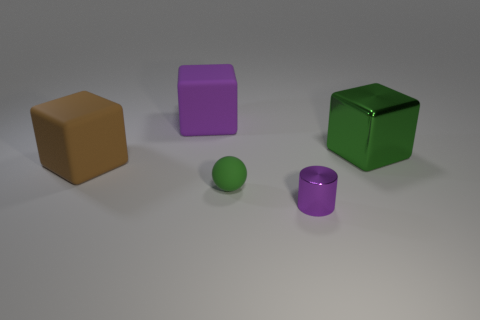Subtract all purple matte blocks. How many blocks are left? 2 Add 2 large purple objects. How many objects exist? 7 Subtract 1 cubes. How many cubes are left? 2 Subtract all large shiny balls. Subtract all cubes. How many objects are left? 2 Add 1 brown things. How many brown things are left? 2 Add 2 purple matte cubes. How many purple matte cubes exist? 3 Subtract 0 yellow balls. How many objects are left? 5 Subtract all cylinders. How many objects are left? 4 Subtract all red cylinders. Subtract all cyan cubes. How many cylinders are left? 1 